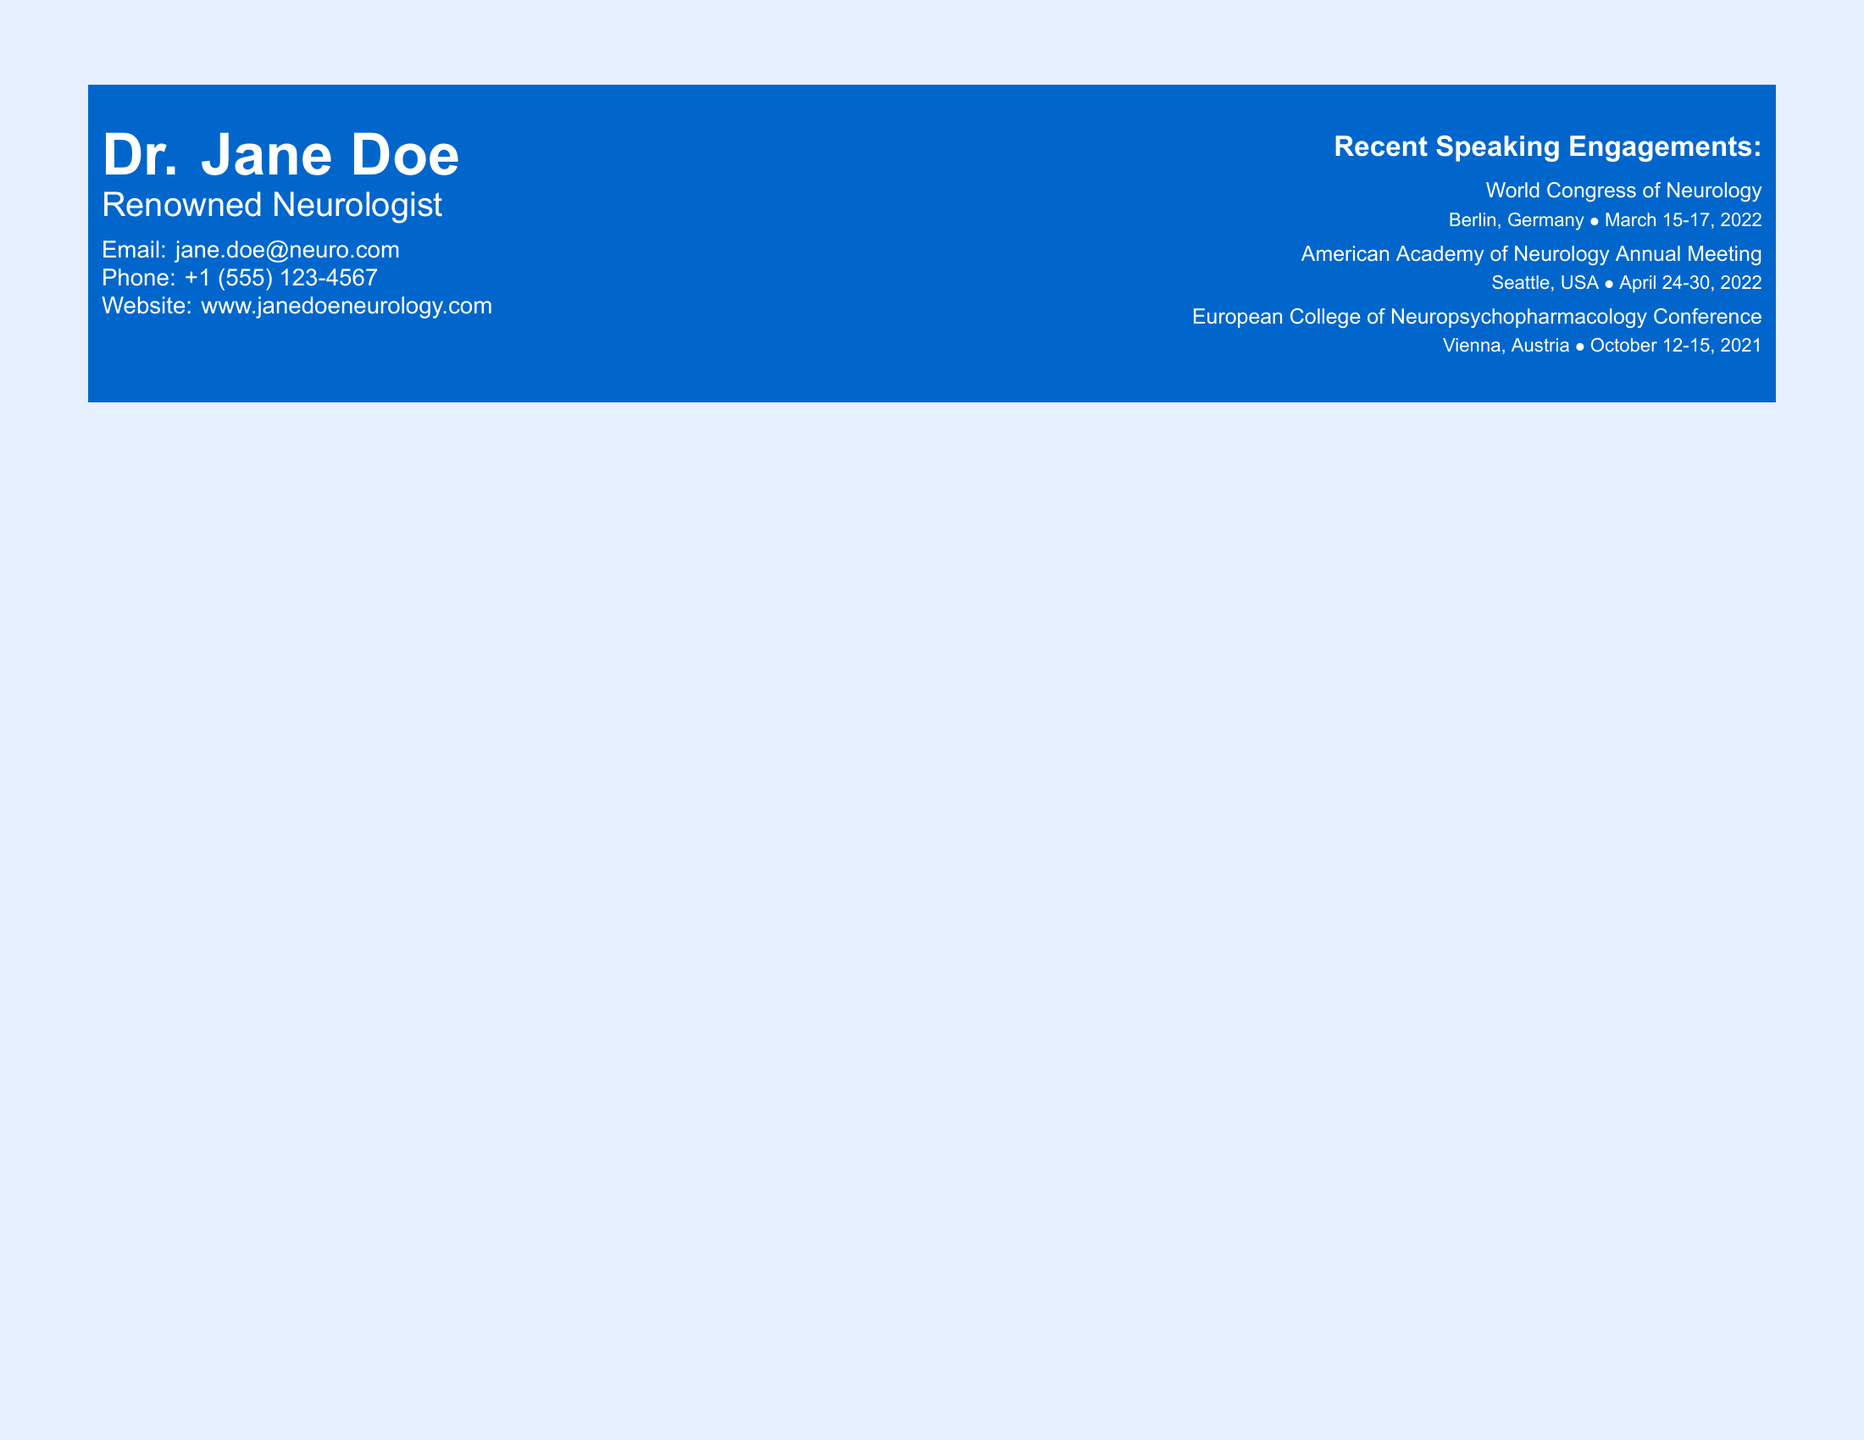What is the name of the neurologist? The name is listed at the top of the document as Dr. Jane Doe.
Answer: Dr. Jane Doe What is Dr. Jane Doe's email address? The email address is provided in the contact information section.
Answer: jane.doe@neuro.com When was the World Congress of Neurology held? The date is specified in the recent speaking engagements section.
Answer: March 15-17, 2022 Where was the American Academy of Neurology Annual Meeting located? The location is detailed in the speaking engagements section.
Answer: Seattle, USA What is the earliest conference listed on the business card? The document specifies the conference with the latest date as October 12-15, 2021.
Answer: European College of Neuropsychopharmacology Conference How many speaking engagements are listed? The document contains three separate speaking engagements.
Answer: 3 What color is the contact information box? The color of the box containing the contact information can be found as it is indicated in the document.
Answer: neuroblue What type of document is this? The structure and content indicate that it is a business card.
Answer: Business card In which city was the European College of Neuropsychopharmacology Conference held? The location details provided in the document specify the city.
Answer: Vienna, Austria 